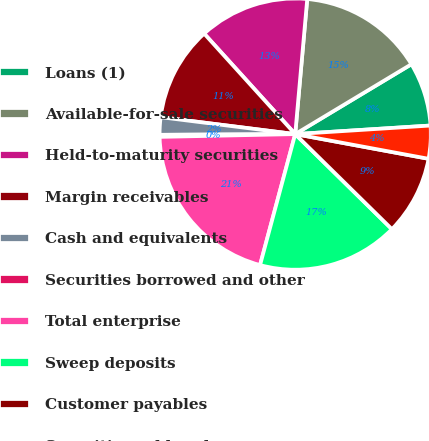Convert chart. <chart><loc_0><loc_0><loc_500><loc_500><pie_chart><fcel>Loans (1)<fcel>Available-for-sale securities<fcel>Held-to-maturity securities<fcel>Margin receivables<fcel>Cash and equivalents<fcel>Securities borrowed and other<fcel>Total enterprise<fcel>Sweep deposits<fcel>Customer payables<fcel>Securities sold under<nl><fcel>7.61%<fcel>14.97%<fcel>13.13%<fcel>11.29%<fcel>2.08%<fcel>0.24%<fcel>20.5%<fcel>16.81%<fcel>9.45%<fcel>3.92%<nl></chart> 